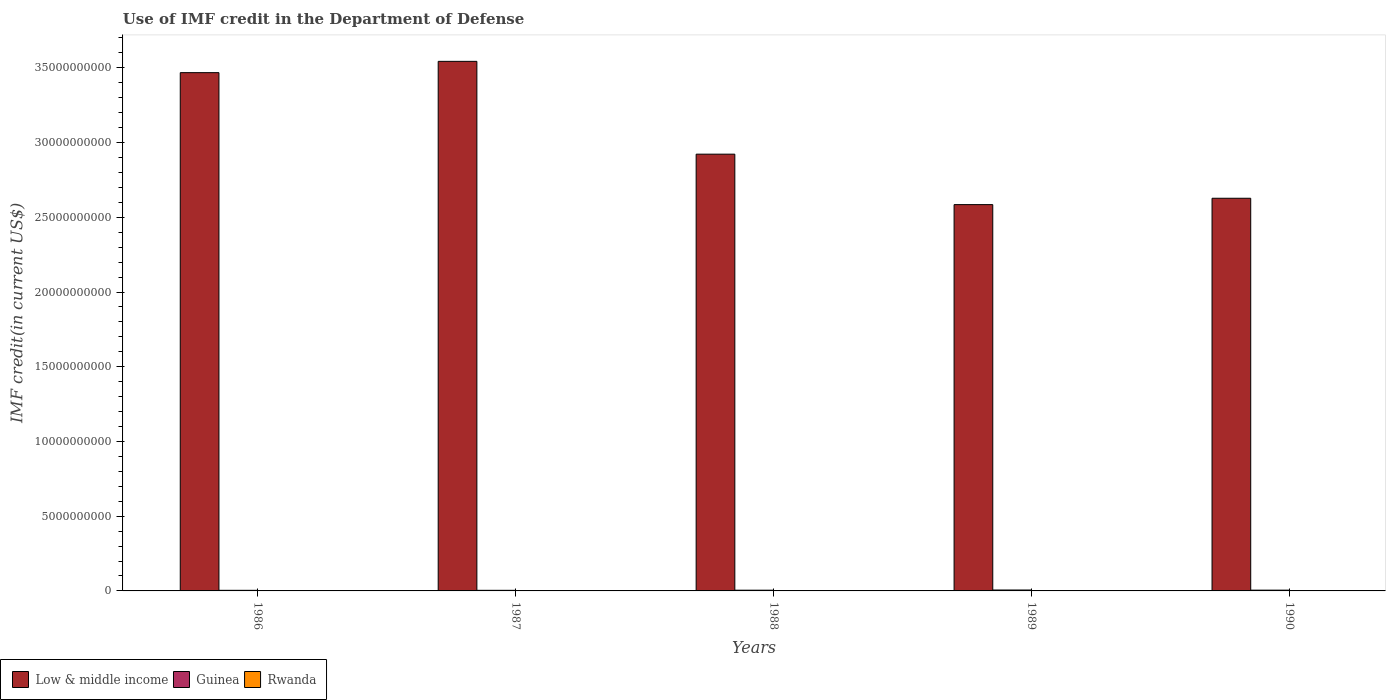How many different coloured bars are there?
Give a very brief answer. 3. How many groups of bars are there?
Give a very brief answer. 5. In how many cases, is the number of bars for a given year not equal to the number of legend labels?
Offer a very short reply. 0. What is the IMF credit in the Department of Defense in Rwanda in 1987?
Provide a succinct answer. 6.95e+06. Across all years, what is the maximum IMF credit in the Department of Defense in Guinea?
Offer a terse response. 6.13e+07. Across all years, what is the minimum IMF credit in the Department of Defense in Guinea?
Your answer should be compact. 4.03e+07. What is the total IMF credit in the Department of Defense in Rwanda in the graph?
Offer a very short reply. 2.02e+07. What is the difference between the IMF credit in the Department of Defense in Rwanda in 1986 and that in 1990?
Keep it short and to the point. 8.49e+06. What is the difference between the IMF credit in the Department of Defense in Rwanda in 1987 and the IMF credit in the Department of Defense in Low & middle income in 1990?
Your response must be concise. -2.63e+1. What is the average IMF credit in the Department of Defense in Guinea per year?
Offer a very short reply. 4.84e+07. In the year 1986, what is the difference between the IMF credit in the Department of Defense in Low & middle income and IMF credit in the Department of Defense in Rwanda?
Offer a terse response. 3.47e+1. What is the ratio of the IMF credit in the Department of Defense in Rwanda in 1988 to that in 1990?
Provide a short and direct response. 36.93. Is the difference between the IMF credit in the Department of Defense in Low & middle income in 1986 and 1990 greater than the difference between the IMF credit in the Department of Defense in Rwanda in 1986 and 1990?
Keep it short and to the point. Yes. What is the difference between the highest and the second highest IMF credit in the Department of Defense in Guinea?
Give a very brief answer. 9.85e+06. What is the difference between the highest and the lowest IMF credit in the Department of Defense in Low & middle income?
Offer a terse response. 9.59e+09. In how many years, is the IMF credit in the Department of Defense in Low & middle income greater than the average IMF credit in the Department of Defense in Low & middle income taken over all years?
Your response must be concise. 2. Is the sum of the IMF credit in the Department of Defense in Rwanda in 1986 and 1987 greater than the maximum IMF credit in the Department of Defense in Low & middle income across all years?
Your answer should be very brief. No. What does the 2nd bar from the left in 1987 represents?
Offer a very short reply. Guinea. What does the 2nd bar from the right in 1990 represents?
Ensure brevity in your answer.  Guinea. Is it the case that in every year, the sum of the IMF credit in the Department of Defense in Rwanda and IMF credit in the Department of Defense in Guinea is greater than the IMF credit in the Department of Defense in Low & middle income?
Keep it short and to the point. No. How many bars are there?
Offer a very short reply. 15. Are the values on the major ticks of Y-axis written in scientific E-notation?
Your response must be concise. No. Does the graph contain grids?
Offer a terse response. No. Where does the legend appear in the graph?
Give a very brief answer. Bottom left. How many legend labels are there?
Your answer should be very brief. 3. What is the title of the graph?
Keep it short and to the point. Use of IMF credit in the Department of Defense. Does "Luxembourg" appear as one of the legend labels in the graph?
Your response must be concise. No. What is the label or title of the Y-axis?
Your response must be concise. IMF credit(in current US$). What is the IMF credit(in current US$) in Low & middle income in 1986?
Give a very brief answer. 3.47e+1. What is the IMF credit(in current US$) of Guinea in 1986?
Provide a succinct answer. 4.03e+07. What is the IMF credit(in current US$) of Rwanda in 1986?
Provide a short and direct response. 8.59e+06. What is the IMF credit(in current US$) in Low & middle income in 1987?
Give a very brief answer. 3.54e+1. What is the IMF credit(in current US$) in Guinea in 1987?
Provide a succinct answer. 4.04e+07. What is the IMF credit(in current US$) of Rwanda in 1987?
Your response must be concise. 6.95e+06. What is the IMF credit(in current US$) in Low & middle income in 1988?
Offer a terse response. 2.92e+1. What is the IMF credit(in current US$) of Guinea in 1988?
Your answer should be very brief. 4.86e+07. What is the IMF credit(in current US$) of Rwanda in 1988?
Offer a terse response. 3.73e+06. What is the IMF credit(in current US$) of Low & middle income in 1989?
Your response must be concise. 2.58e+1. What is the IMF credit(in current US$) in Guinea in 1989?
Make the answer very short. 6.13e+07. What is the IMF credit(in current US$) in Rwanda in 1989?
Keep it short and to the point. 8.53e+05. What is the IMF credit(in current US$) of Low & middle income in 1990?
Ensure brevity in your answer.  2.63e+1. What is the IMF credit(in current US$) in Guinea in 1990?
Offer a terse response. 5.15e+07. What is the IMF credit(in current US$) in Rwanda in 1990?
Provide a short and direct response. 1.01e+05. Across all years, what is the maximum IMF credit(in current US$) of Low & middle income?
Keep it short and to the point. 3.54e+1. Across all years, what is the maximum IMF credit(in current US$) of Guinea?
Your answer should be very brief. 6.13e+07. Across all years, what is the maximum IMF credit(in current US$) in Rwanda?
Offer a terse response. 8.59e+06. Across all years, what is the minimum IMF credit(in current US$) of Low & middle income?
Provide a succinct answer. 2.58e+1. Across all years, what is the minimum IMF credit(in current US$) of Guinea?
Make the answer very short. 4.03e+07. Across all years, what is the minimum IMF credit(in current US$) in Rwanda?
Give a very brief answer. 1.01e+05. What is the total IMF credit(in current US$) of Low & middle income in the graph?
Keep it short and to the point. 1.51e+11. What is the total IMF credit(in current US$) of Guinea in the graph?
Keep it short and to the point. 2.42e+08. What is the total IMF credit(in current US$) in Rwanda in the graph?
Your answer should be compact. 2.02e+07. What is the difference between the IMF credit(in current US$) in Low & middle income in 1986 and that in 1987?
Your response must be concise. -7.56e+08. What is the difference between the IMF credit(in current US$) in Guinea in 1986 and that in 1987?
Provide a short and direct response. -1.64e+05. What is the difference between the IMF credit(in current US$) of Rwanda in 1986 and that in 1987?
Provide a short and direct response. 1.64e+06. What is the difference between the IMF credit(in current US$) in Low & middle income in 1986 and that in 1988?
Your answer should be compact. 5.45e+09. What is the difference between the IMF credit(in current US$) in Guinea in 1986 and that in 1988?
Your answer should be very brief. -8.28e+06. What is the difference between the IMF credit(in current US$) of Rwanda in 1986 and that in 1988?
Give a very brief answer. 4.86e+06. What is the difference between the IMF credit(in current US$) in Low & middle income in 1986 and that in 1989?
Give a very brief answer. 8.83e+09. What is the difference between the IMF credit(in current US$) in Guinea in 1986 and that in 1989?
Your response must be concise. -2.10e+07. What is the difference between the IMF credit(in current US$) of Rwanda in 1986 and that in 1989?
Offer a terse response. 7.74e+06. What is the difference between the IMF credit(in current US$) in Low & middle income in 1986 and that in 1990?
Your answer should be very brief. 8.40e+09. What is the difference between the IMF credit(in current US$) of Guinea in 1986 and that in 1990?
Offer a terse response. -1.12e+07. What is the difference between the IMF credit(in current US$) of Rwanda in 1986 and that in 1990?
Your answer should be compact. 8.49e+06. What is the difference between the IMF credit(in current US$) in Low & middle income in 1987 and that in 1988?
Ensure brevity in your answer.  6.21e+09. What is the difference between the IMF credit(in current US$) of Guinea in 1987 and that in 1988?
Offer a very short reply. -8.12e+06. What is the difference between the IMF credit(in current US$) in Rwanda in 1987 and that in 1988?
Offer a very short reply. 3.22e+06. What is the difference between the IMF credit(in current US$) in Low & middle income in 1987 and that in 1989?
Make the answer very short. 9.59e+09. What is the difference between the IMF credit(in current US$) in Guinea in 1987 and that in 1989?
Your answer should be very brief. -2.09e+07. What is the difference between the IMF credit(in current US$) of Rwanda in 1987 and that in 1989?
Offer a terse response. 6.09e+06. What is the difference between the IMF credit(in current US$) of Low & middle income in 1987 and that in 1990?
Offer a very short reply. 9.16e+09. What is the difference between the IMF credit(in current US$) of Guinea in 1987 and that in 1990?
Your response must be concise. -1.10e+07. What is the difference between the IMF credit(in current US$) in Rwanda in 1987 and that in 1990?
Ensure brevity in your answer.  6.85e+06. What is the difference between the IMF credit(in current US$) of Low & middle income in 1988 and that in 1989?
Provide a short and direct response. 3.38e+09. What is the difference between the IMF credit(in current US$) of Guinea in 1988 and that in 1989?
Give a very brief answer. -1.27e+07. What is the difference between the IMF credit(in current US$) of Rwanda in 1988 and that in 1989?
Your answer should be very brief. 2.88e+06. What is the difference between the IMF credit(in current US$) of Low & middle income in 1988 and that in 1990?
Make the answer very short. 2.95e+09. What is the difference between the IMF credit(in current US$) in Guinea in 1988 and that in 1990?
Provide a short and direct response. -2.89e+06. What is the difference between the IMF credit(in current US$) in Rwanda in 1988 and that in 1990?
Offer a very short reply. 3.63e+06. What is the difference between the IMF credit(in current US$) of Low & middle income in 1989 and that in 1990?
Keep it short and to the point. -4.25e+08. What is the difference between the IMF credit(in current US$) of Guinea in 1989 and that in 1990?
Offer a very short reply. 9.85e+06. What is the difference between the IMF credit(in current US$) of Rwanda in 1989 and that in 1990?
Ensure brevity in your answer.  7.52e+05. What is the difference between the IMF credit(in current US$) in Low & middle income in 1986 and the IMF credit(in current US$) in Guinea in 1987?
Ensure brevity in your answer.  3.46e+1. What is the difference between the IMF credit(in current US$) in Low & middle income in 1986 and the IMF credit(in current US$) in Rwanda in 1987?
Offer a terse response. 3.47e+1. What is the difference between the IMF credit(in current US$) of Guinea in 1986 and the IMF credit(in current US$) of Rwanda in 1987?
Your response must be concise. 3.33e+07. What is the difference between the IMF credit(in current US$) of Low & middle income in 1986 and the IMF credit(in current US$) of Guinea in 1988?
Ensure brevity in your answer.  3.46e+1. What is the difference between the IMF credit(in current US$) of Low & middle income in 1986 and the IMF credit(in current US$) of Rwanda in 1988?
Give a very brief answer. 3.47e+1. What is the difference between the IMF credit(in current US$) of Guinea in 1986 and the IMF credit(in current US$) of Rwanda in 1988?
Your answer should be very brief. 3.65e+07. What is the difference between the IMF credit(in current US$) in Low & middle income in 1986 and the IMF credit(in current US$) in Guinea in 1989?
Give a very brief answer. 3.46e+1. What is the difference between the IMF credit(in current US$) in Low & middle income in 1986 and the IMF credit(in current US$) in Rwanda in 1989?
Your answer should be compact. 3.47e+1. What is the difference between the IMF credit(in current US$) in Guinea in 1986 and the IMF credit(in current US$) in Rwanda in 1989?
Your answer should be very brief. 3.94e+07. What is the difference between the IMF credit(in current US$) of Low & middle income in 1986 and the IMF credit(in current US$) of Guinea in 1990?
Your response must be concise. 3.46e+1. What is the difference between the IMF credit(in current US$) of Low & middle income in 1986 and the IMF credit(in current US$) of Rwanda in 1990?
Your answer should be compact. 3.47e+1. What is the difference between the IMF credit(in current US$) of Guinea in 1986 and the IMF credit(in current US$) of Rwanda in 1990?
Provide a succinct answer. 4.02e+07. What is the difference between the IMF credit(in current US$) in Low & middle income in 1987 and the IMF credit(in current US$) in Guinea in 1988?
Make the answer very short. 3.54e+1. What is the difference between the IMF credit(in current US$) of Low & middle income in 1987 and the IMF credit(in current US$) of Rwanda in 1988?
Ensure brevity in your answer.  3.54e+1. What is the difference between the IMF credit(in current US$) of Guinea in 1987 and the IMF credit(in current US$) of Rwanda in 1988?
Your answer should be compact. 3.67e+07. What is the difference between the IMF credit(in current US$) of Low & middle income in 1987 and the IMF credit(in current US$) of Guinea in 1989?
Your answer should be very brief. 3.54e+1. What is the difference between the IMF credit(in current US$) of Low & middle income in 1987 and the IMF credit(in current US$) of Rwanda in 1989?
Give a very brief answer. 3.54e+1. What is the difference between the IMF credit(in current US$) of Guinea in 1987 and the IMF credit(in current US$) of Rwanda in 1989?
Offer a terse response. 3.96e+07. What is the difference between the IMF credit(in current US$) in Low & middle income in 1987 and the IMF credit(in current US$) in Guinea in 1990?
Make the answer very short. 3.54e+1. What is the difference between the IMF credit(in current US$) of Low & middle income in 1987 and the IMF credit(in current US$) of Rwanda in 1990?
Your response must be concise. 3.54e+1. What is the difference between the IMF credit(in current US$) in Guinea in 1987 and the IMF credit(in current US$) in Rwanda in 1990?
Provide a short and direct response. 4.03e+07. What is the difference between the IMF credit(in current US$) in Low & middle income in 1988 and the IMF credit(in current US$) in Guinea in 1989?
Provide a succinct answer. 2.92e+1. What is the difference between the IMF credit(in current US$) in Low & middle income in 1988 and the IMF credit(in current US$) in Rwanda in 1989?
Your answer should be very brief. 2.92e+1. What is the difference between the IMF credit(in current US$) of Guinea in 1988 and the IMF credit(in current US$) of Rwanda in 1989?
Your answer should be compact. 4.77e+07. What is the difference between the IMF credit(in current US$) in Low & middle income in 1988 and the IMF credit(in current US$) in Guinea in 1990?
Offer a terse response. 2.92e+1. What is the difference between the IMF credit(in current US$) of Low & middle income in 1988 and the IMF credit(in current US$) of Rwanda in 1990?
Offer a terse response. 2.92e+1. What is the difference between the IMF credit(in current US$) of Guinea in 1988 and the IMF credit(in current US$) of Rwanda in 1990?
Provide a succinct answer. 4.85e+07. What is the difference between the IMF credit(in current US$) in Low & middle income in 1989 and the IMF credit(in current US$) in Guinea in 1990?
Provide a short and direct response. 2.58e+1. What is the difference between the IMF credit(in current US$) in Low & middle income in 1989 and the IMF credit(in current US$) in Rwanda in 1990?
Offer a terse response. 2.58e+1. What is the difference between the IMF credit(in current US$) in Guinea in 1989 and the IMF credit(in current US$) in Rwanda in 1990?
Your answer should be compact. 6.12e+07. What is the average IMF credit(in current US$) in Low & middle income per year?
Your answer should be very brief. 3.03e+1. What is the average IMF credit(in current US$) in Guinea per year?
Provide a succinct answer. 4.84e+07. What is the average IMF credit(in current US$) of Rwanda per year?
Offer a terse response. 4.04e+06. In the year 1986, what is the difference between the IMF credit(in current US$) of Low & middle income and IMF credit(in current US$) of Guinea?
Ensure brevity in your answer.  3.46e+1. In the year 1986, what is the difference between the IMF credit(in current US$) in Low & middle income and IMF credit(in current US$) in Rwanda?
Keep it short and to the point. 3.47e+1. In the year 1986, what is the difference between the IMF credit(in current US$) in Guinea and IMF credit(in current US$) in Rwanda?
Offer a very short reply. 3.17e+07. In the year 1987, what is the difference between the IMF credit(in current US$) in Low & middle income and IMF credit(in current US$) in Guinea?
Offer a terse response. 3.54e+1. In the year 1987, what is the difference between the IMF credit(in current US$) in Low & middle income and IMF credit(in current US$) in Rwanda?
Your response must be concise. 3.54e+1. In the year 1987, what is the difference between the IMF credit(in current US$) of Guinea and IMF credit(in current US$) of Rwanda?
Offer a very short reply. 3.35e+07. In the year 1988, what is the difference between the IMF credit(in current US$) of Low & middle income and IMF credit(in current US$) of Guinea?
Give a very brief answer. 2.92e+1. In the year 1988, what is the difference between the IMF credit(in current US$) of Low & middle income and IMF credit(in current US$) of Rwanda?
Keep it short and to the point. 2.92e+1. In the year 1988, what is the difference between the IMF credit(in current US$) in Guinea and IMF credit(in current US$) in Rwanda?
Give a very brief answer. 4.48e+07. In the year 1989, what is the difference between the IMF credit(in current US$) of Low & middle income and IMF credit(in current US$) of Guinea?
Your response must be concise. 2.58e+1. In the year 1989, what is the difference between the IMF credit(in current US$) in Low & middle income and IMF credit(in current US$) in Rwanda?
Make the answer very short. 2.58e+1. In the year 1989, what is the difference between the IMF credit(in current US$) of Guinea and IMF credit(in current US$) of Rwanda?
Offer a terse response. 6.04e+07. In the year 1990, what is the difference between the IMF credit(in current US$) in Low & middle income and IMF credit(in current US$) in Guinea?
Keep it short and to the point. 2.62e+1. In the year 1990, what is the difference between the IMF credit(in current US$) of Low & middle income and IMF credit(in current US$) of Rwanda?
Provide a short and direct response. 2.63e+1. In the year 1990, what is the difference between the IMF credit(in current US$) in Guinea and IMF credit(in current US$) in Rwanda?
Ensure brevity in your answer.  5.14e+07. What is the ratio of the IMF credit(in current US$) in Low & middle income in 1986 to that in 1987?
Make the answer very short. 0.98. What is the ratio of the IMF credit(in current US$) of Guinea in 1986 to that in 1987?
Ensure brevity in your answer.  1. What is the ratio of the IMF credit(in current US$) of Rwanda in 1986 to that in 1987?
Make the answer very short. 1.24. What is the ratio of the IMF credit(in current US$) in Low & middle income in 1986 to that in 1988?
Provide a succinct answer. 1.19. What is the ratio of the IMF credit(in current US$) of Guinea in 1986 to that in 1988?
Offer a very short reply. 0.83. What is the ratio of the IMF credit(in current US$) of Rwanda in 1986 to that in 1988?
Ensure brevity in your answer.  2.3. What is the ratio of the IMF credit(in current US$) in Low & middle income in 1986 to that in 1989?
Offer a terse response. 1.34. What is the ratio of the IMF credit(in current US$) of Guinea in 1986 to that in 1989?
Your answer should be very brief. 0.66. What is the ratio of the IMF credit(in current US$) in Rwanda in 1986 to that in 1989?
Your answer should be very brief. 10.07. What is the ratio of the IMF credit(in current US$) in Low & middle income in 1986 to that in 1990?
Ensure brevity in your answer.  1.32. What is the ratio of the IMF credit(in current US$) in Guinea in 1986 to that in 1990?
Provide a succinct answer. 0.78. What is the ratio of the IMF credit(in current US$) in Rwanda in 1986 to that in 1990?
Your answer should be very brief. 85.06. What is the ratio of the IMF credit(in current US$) in Low & middle income in 1987 to that in 1988?
Provide a short and direct response. 1.21. What is the ratio of the IMF credit(in current US$) in Guinea in 1987 to that in 1988?
Your answer should be very brief. 0.83. What is the ratio of the IMF credit(in current US$) of Rwanda in 1987 to that in 1988?
Keep it short and to the point. 1.86. What is the ratio of the IMF credit(in current US$) in Low & middle income in 1987 to that in 1989?
Ensure brevity in your answer.  1.37. What is the ratio of the IMF credit(in current US$) of Guinea in 1987 to that in 1989?
Your response must be concise. 0.66. What is the ratio of the IMF credit(in current US$) in Rwanda in 1987 to that in 1989?
Offer a very short reply. 8.14. What is the ratio of the IMF credit(in current US$) in Low & middle income in 1987 to that in 1990?
Offer a very short reply. 1.35. What is the ratio of the IMF credit(in current US$) of Guinea in 1987 to that in 1990?
Your answer should be very brief. 0.79. What is the ratio of the IMF credit(in current US$) in Rwanda in 1987 to that in 1990?
Offer a very short reply. 68.78. What is the ratio of the IMF credit(in current US$) in Low & middle income in 1988 to that in 1989?
Ensure brevity in your answer.  1.13. What is the ratio of the IMF credit(in current US$) in Guinea in 1988 to that in 1989?
Ensure brevity in your answer.  0.79. What is the ratio of the IMF credit(in current US$) in Rwanda in 1988 to that in 1989?
Give a very brief answer. 4.37. What is the ratio of the IMF credit(in current US$) in Low & middle income in 1988 to that in 1990?
Offer a terse response. 1.11. What is the ratio of the IMF credit(in current US$) in Guinea in 1988 to that in 1990?
Offer a terse response. 0.94. What is the ratio of the IMF credit(in current US$) of Rwanda in 1988 to that in 1990?
Your answer should be very brief. 36.93. What is the ratio of the IMF credit(in current US$) in Low & middle income in 1989 to that in 1990?
Provide a succinct answer. 0.98. What is the ratio of the IMF credit(in current US$) in Guinea in 1989 to that in 1990?
Keep it short and to the point. 1.19. What is the ratio of the IMF credit(in current US$) in Rwanda in 1989 to that in 1990?
Offer a terse response. 8.45. What is the difference between the highest and the second highest IMF credit(in current US$) of Low & middle income?
Offer a very short reply. 7.56e+08. What is the difference between the highest and the second highest IMF credit(in current US$) in Guinea?
Ensure brevity in your answer.  9.85e+06. What is the difference between the highest and the second highest IMF credit(in current US$) of Rwanda?
Your answer should be compact. 1.64e+06. What is the difference between the highest and the lowest IMF credit(in current US$) in Low & middle income?
Provide a succinct answer. 9.59e+09. What is the difference between the highest and the lowest IMF credit(in current US$) of Guinea?
Offer a very short reply. 2.10e+07. What is the difference between the highest and the lowest IMF credit(in current US$) in Rwanda?
Ensure brevity in your answer.  8.49e+06. 